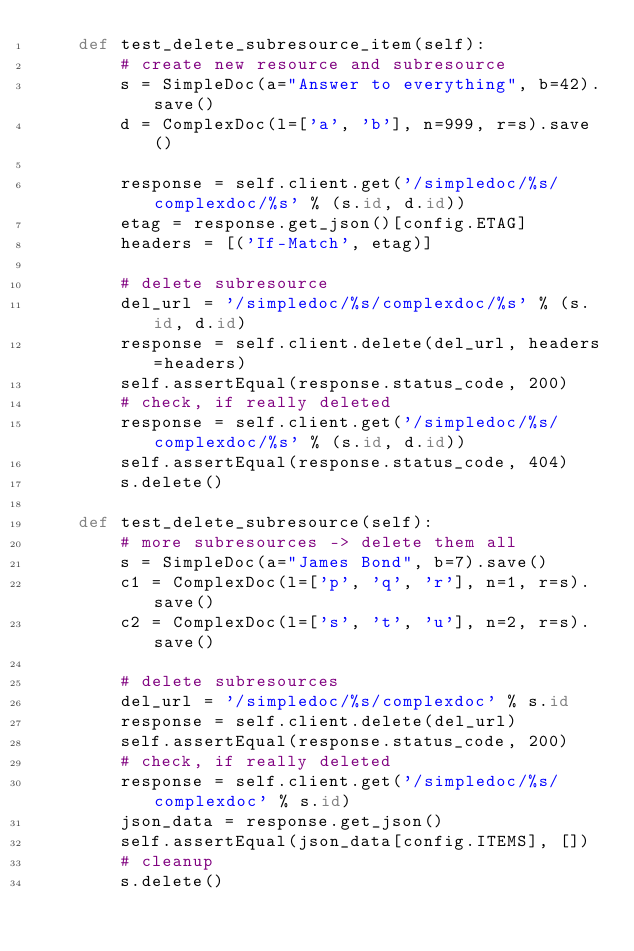<code> <loc_0><loc_0><loc_500><loc_500><_Python_>    def test_delete_subresource_item(self):
        # create new resource and subresource
        s = SimpleDoc(a="Answer to everything", b=42).save()
        d = ComplexDoc(l=['a', 'b'], n=999, r=s).save()

        response = self.client.get('/simpledoc/%s/complexdoc/%s' % (s.id, d.id))
        etag = response.get_json()[config.ETAG]
        headers = [('If-Match', etag)]

        # delete subresource
        del_url = '/simpledoc/%s/complexdoc/%s' % (s.id, d.id)
        response = self.client.delete(del_url, headers=headers)
        self.assertEqual(response.status_code, 200)
        # check, if really deleted
        response = self.client.get('/simpledoc/%s/complexdoc/%s' % (s.id, d.id))
        self.assertEqual(response.status_code, 404)
        s.delete()

    def test_delete_subresource(self):
        # more subresources -> delete them all
        s = SimpleDoc(a="James Bond", b=7).save()
        c1 = ComplexDoc(l=['p', 'q', 'r'], n=1, r=s).save()
        c2 = ComplexDoc(l=['s', 't', 'u'], n=2, r=s).save()

        # delete subresources
        del_url = '/simpledoc/%s/complexdoc' % s.id
        response = self.client.delete(del_url)
        self.assertEqual(response.status_code, 200)
        # check, if really deleted
        response = self.client.get('/simpledoc/%s/complexdoc' % s.id)
        json_data = response.get_json()
        self.assertEqual(json_data[config.ITEMS], [])
        # cleanup
        s.delete()
</code> 